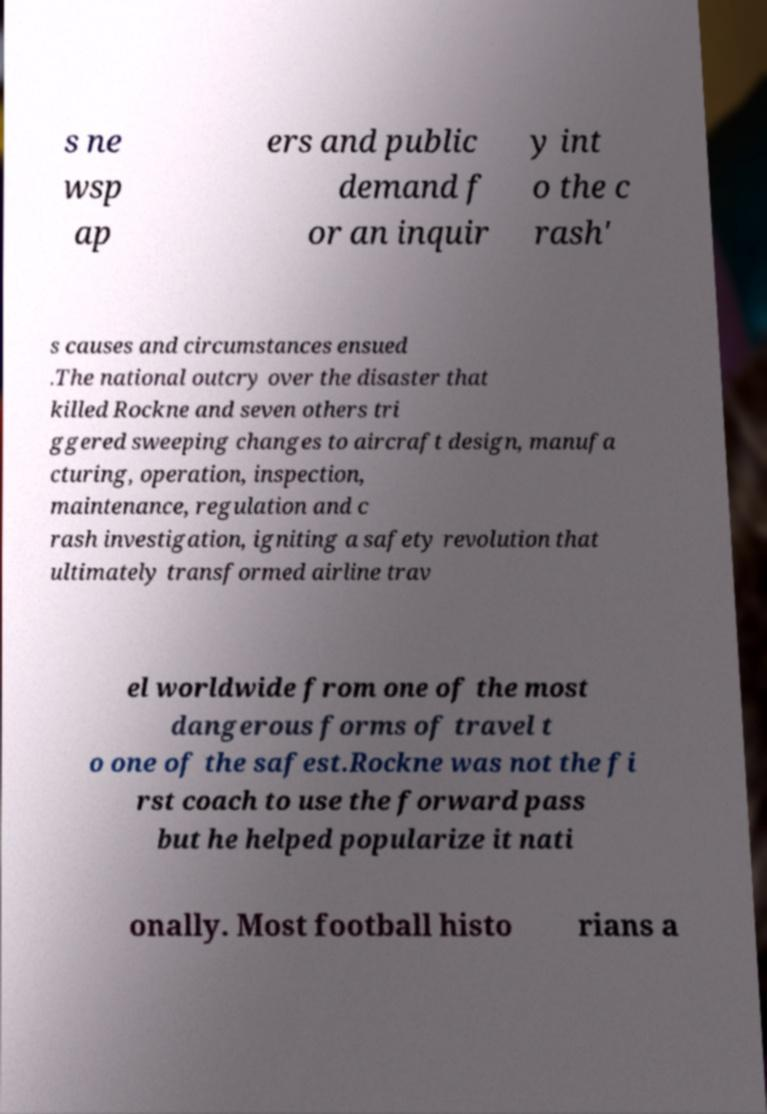Can you read and provide the text displayed in the image?This photo seems to have some interesting text. Can you extract and type it out for me? s ne wsp ap ers and public demand f or an inquir y int o the c rash' s causes and circumstances ensued .The national outcry over the disaster that killed Rockne and seven others tri ggered sweeping changes to aircraft design, manufa cturing, operation, inspection, maintenance, regulation and c rash investigation, igniting a safety revolution that ultimately transformed airline trav el worldwide from one of the most dangerous forms of travel t o one of the safest.Rockne was not the fi rst coach to use the forward pass but he helped popularize it nati onally. Most football histo rians a 